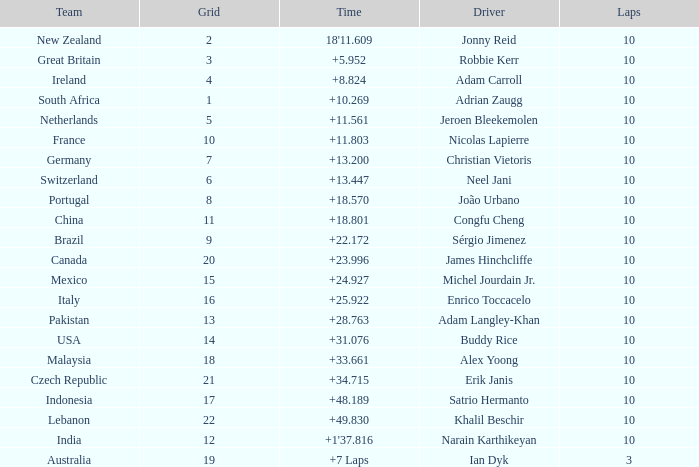What is the Grid number for the Team from Italy? 1.0. 